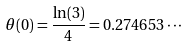<formula> <loc_0><loc_0><loc_500><loc_500>\theta ( 0 ) = \frac { \ln ( 3 ) } { 4 } = 0 . 2 7 4 6 5 3 \cdots</formula> 